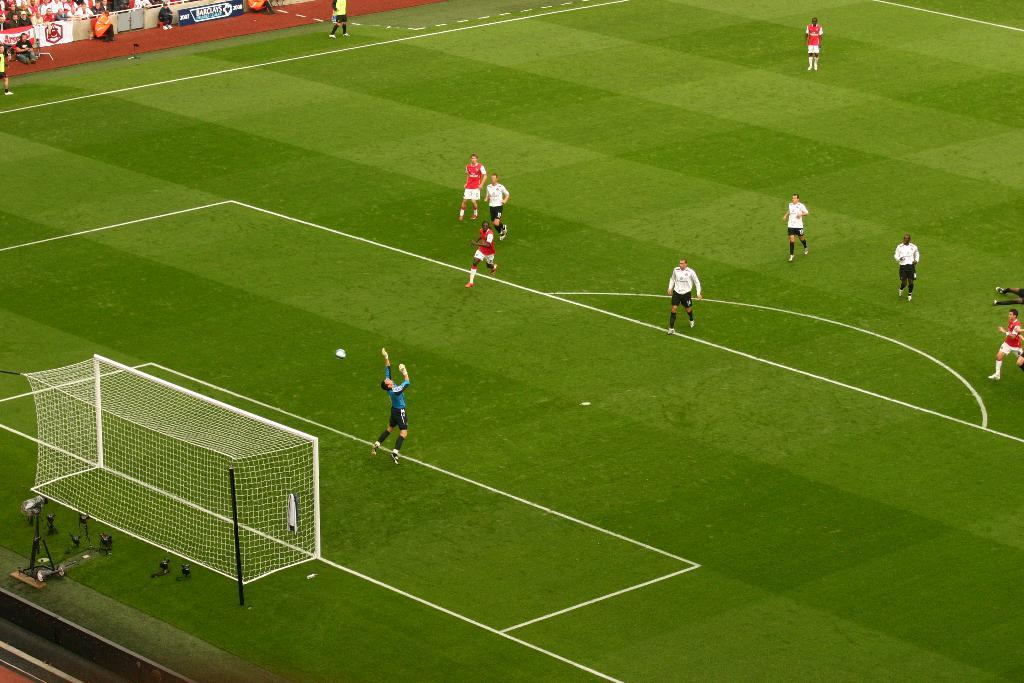What are the people in the foreground of the image doing? The people in the foreground of the image are playing. What object is present in the foreground of the image alongside the people? There is a net in the foreground of the image. What can be seen in the top left side of the image? There are posters and people in the top left side of the image. What type of mint is growing in the cellar in the image? There is no mention of a cellar or mint in the image; it features people playing with a net and posters in the background. 